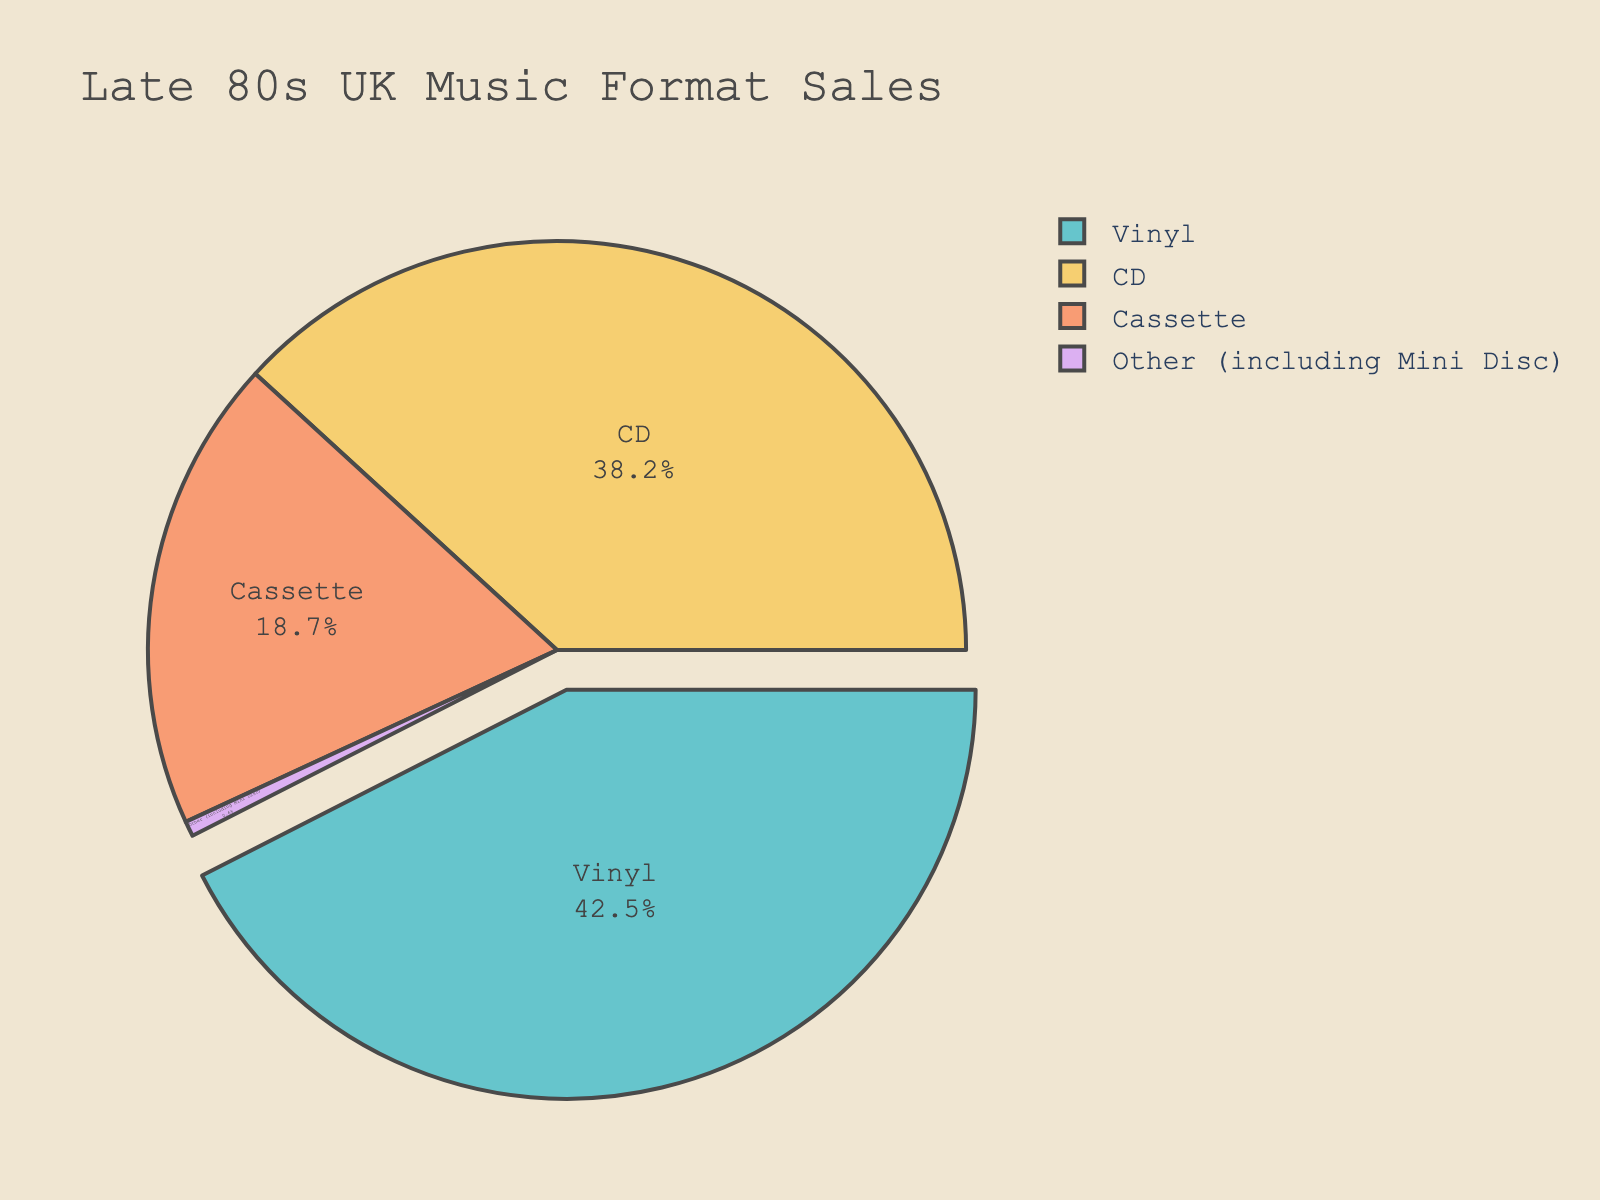What is the percentage of Vinyl sales? The figure shows the percentage directly next to the label 'Vinyl'.
Answer: 42.5% Which music format has the second highest sales percentage? By looking at the data labels, the second highest percentage is next to 'CD'.
Answer: CD What is the total percentage of sales for Vinyl and CD combined? Add the percentages for Vinyl and CD: 42.5% + 38.2% = 80.7%.
Answer: 80.7% Is the percentage of Cassette sales more or less than 20%? The label for Cassette sales shows 18.7%, which is less than 20%.
Answer: Less By how much does Vinyl sales outperform Cassette sales percentage-wise? Subtract the percentage of Cassette sales from Vinyl sales: 42.5% - 18.7% = 23.8%.
Answer: 23.8% Which music format has the smallest sales percentage? The segment labeled 'Other (including Mini Disc)' shows the smallest percentage, 0.6%.
Answer: Other (including Mini Disc) What is the ratio of CD sales to Cassette sales? Divide the percentage of CD sales by Cassette sales: 38.2 / 18.7 = 2.04.
Answer: 2.04 What portion of the pie chart is taken up by formats other than Vinyl and CD? First, sum the percentages of Cassette and Other: 18.7% + 0.6% = 19.3%.
Answer: 19.3% Are the combined sales percentages of Cassette and Other more or less than the sales of CD? Add the percentages of Cassette and Other: 18.7% + 0.6% = 19.3%. Compare this to CD which is 38.2%. 19.3% < 38.2%.
Answer: Less What percentage of the total music format sales is not accounted for by Vinyl? Subtract the percentage of Vinyl sales from 100%: 100% - 42.5% = 57.5%.
Answer: 57.5% 